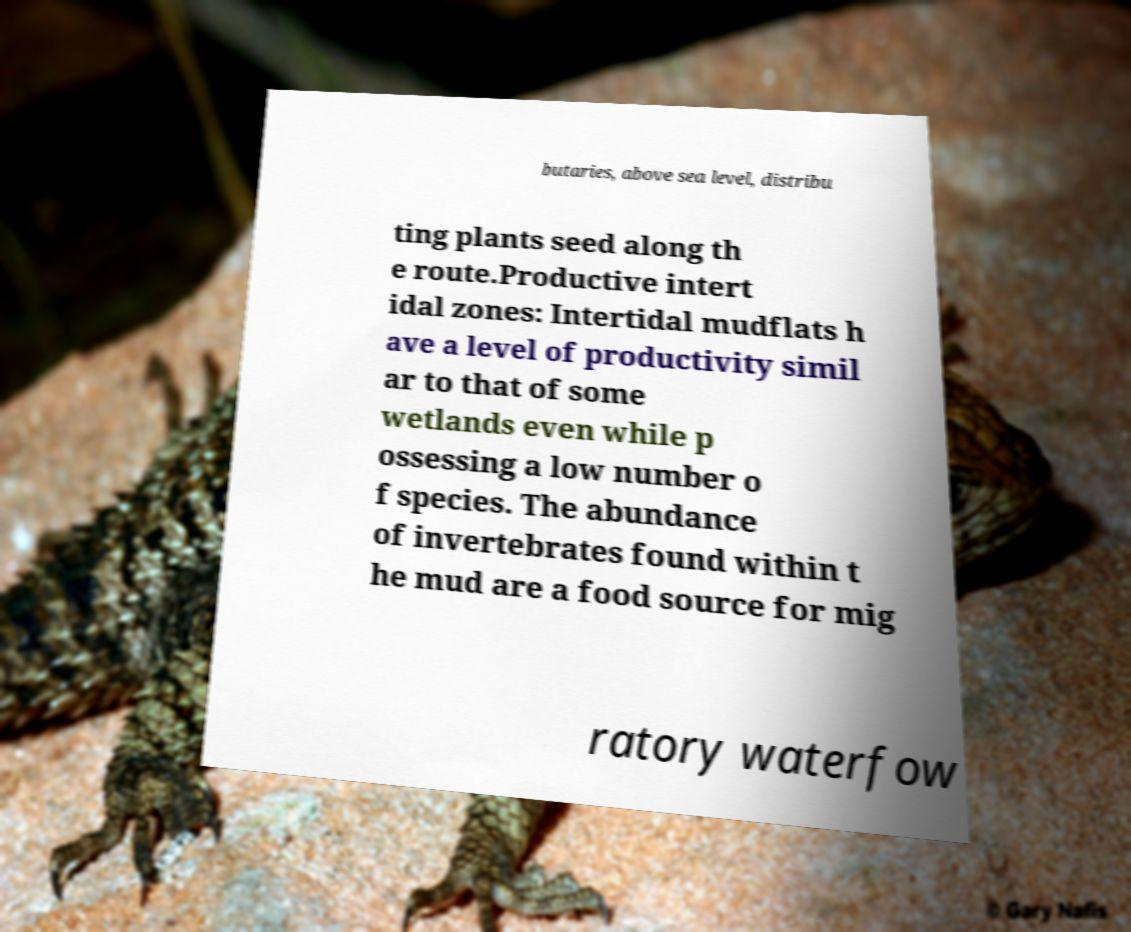I need the written content from this picture converted into text. Can you do that? butaries, above sea level, distribu ting plants seed along th e route.Productive intert idal zones: Intertidal mudflats h ave a level of productivity simil ar to that of some wetlands even while p ossessing a low number o f species. The abundance of invertebrates found within t he mud are a food source for mig ratory waterfow 